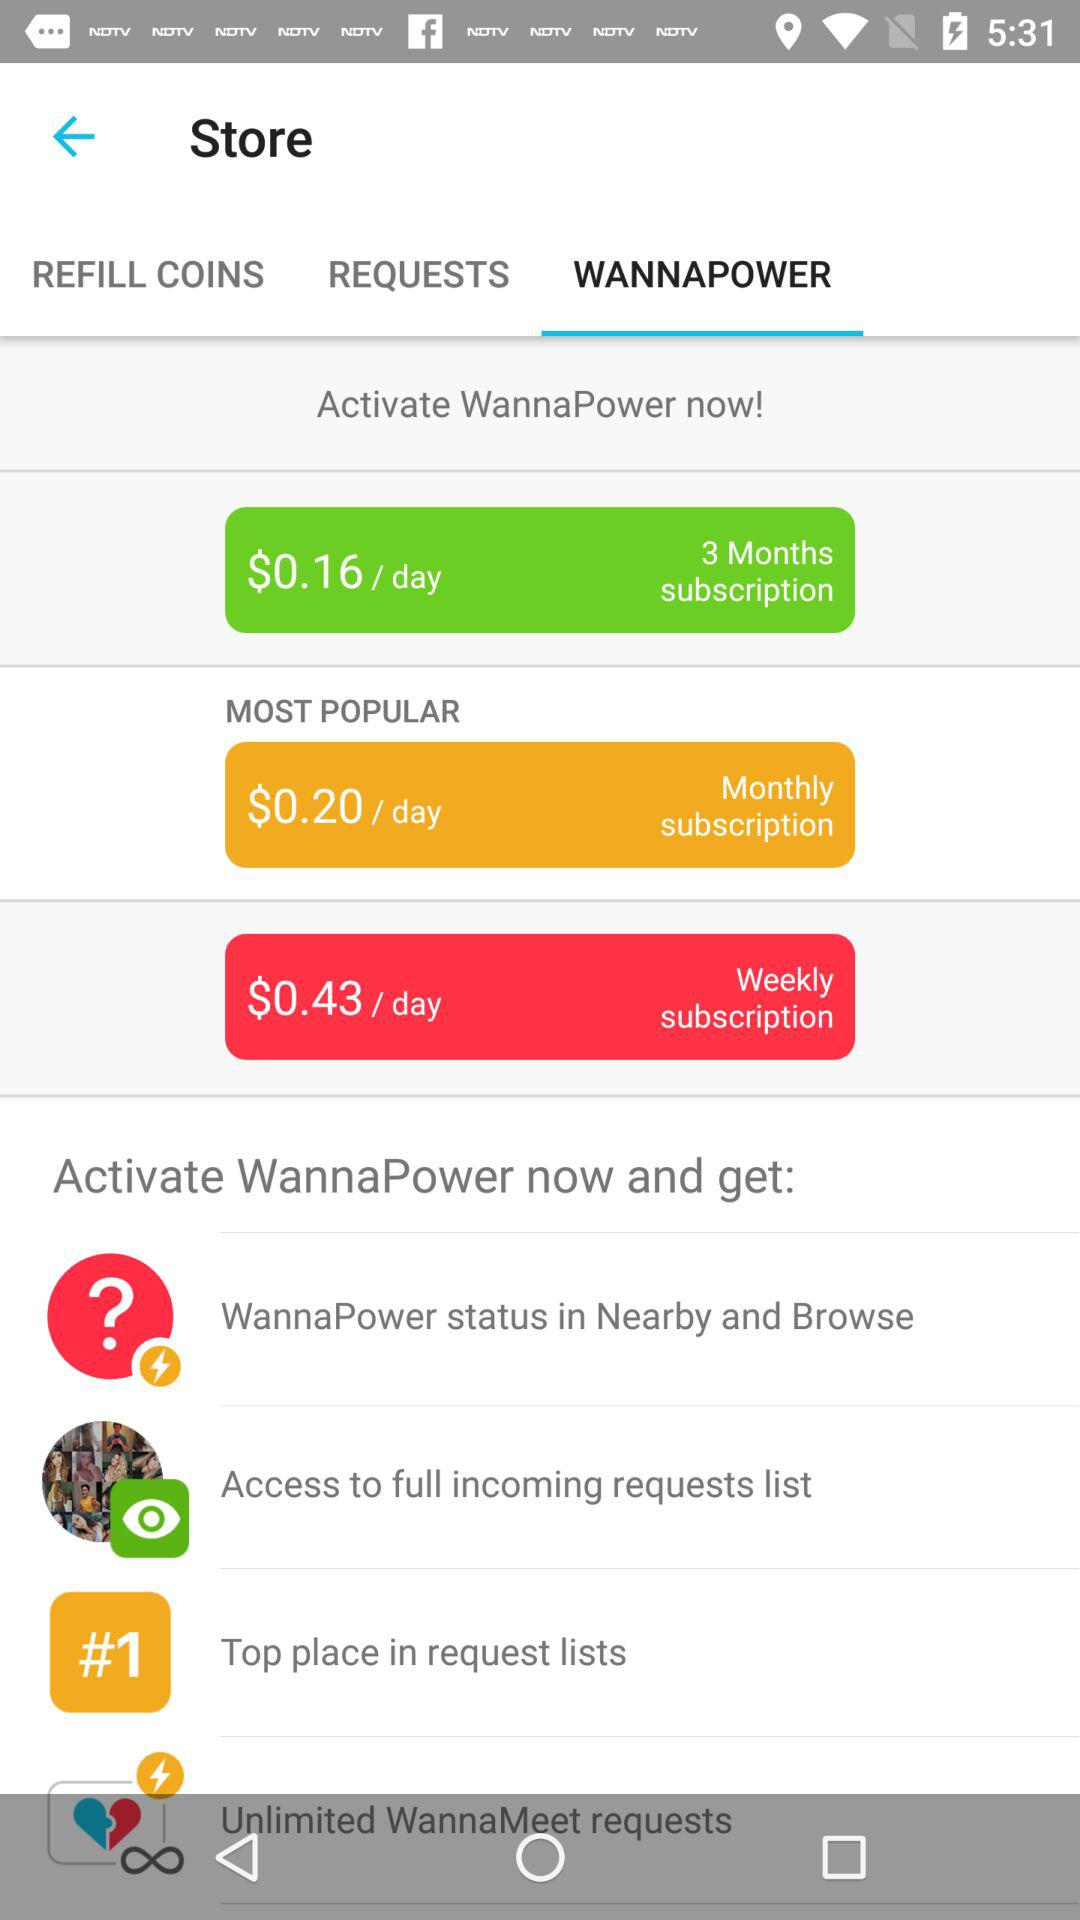What are the different plans available? The different plans available are "3 Months subscription", "Monthly subscription" and "Weekly subscription". 